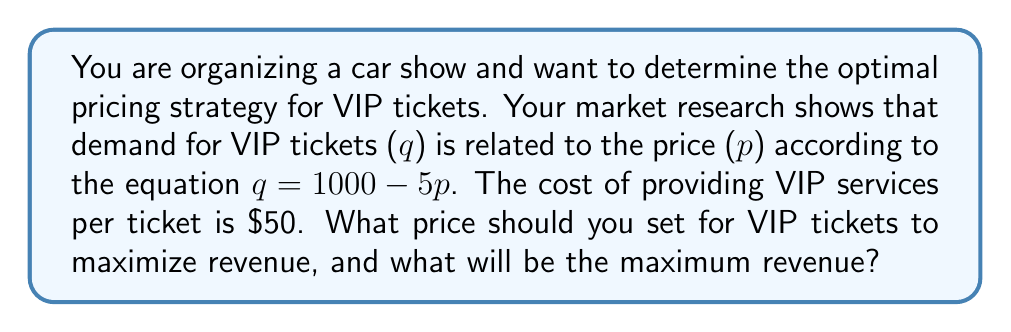Show me your answer to this math problem. To solve this problem, we'll follow these steps:

1. Define the revenue function
2. Find the derivative of the revenue function
3. Set the derivative equal to zero and solve for the optimal price
4. Calculate the maximum revenue

Step 1: Define the revenue function
Revenue ($R$) is equal to price ($p$) times quantity ($q$):
$$R = pq = p(1000 - 5p) = 1000p - 5p^2$$

Step 2: Find the derivative of the revenue function
To find the maximum revenue, we need to differentiate $R$ with respect to $p$:
$$\frac{dR}{dp} = 1000 - 10p$$

Step 3: Set the derivative equal to zero and solve for the optimal price
$$1000 - 10p = 0$$
$$10p = 1000$$
$$p = 100$$

To confirm this is a maximum, we can check that the second derivative is negative:
$$\frac{d^2R}{dp^2} = -10 < 0$$

Step 4: Calculate the maximum revenue
At $p = 100$, the quantity sold will be:
$$q = 1000 - 5(100) = 500$$

The maximum revenue is:
$$R = 100 \times 500 = \$50,000$$

Note that this price maximizes revenue, not profit. To maximize profit, we would need to consider the cost of $\$50$ per ticket. The profit-maximizing price would be slightly higher than $\$100$.
Answer: The optimal price for VIP tickets to maximize revenue is $\$100$, and the maximum revenue is $\$50,000$. 